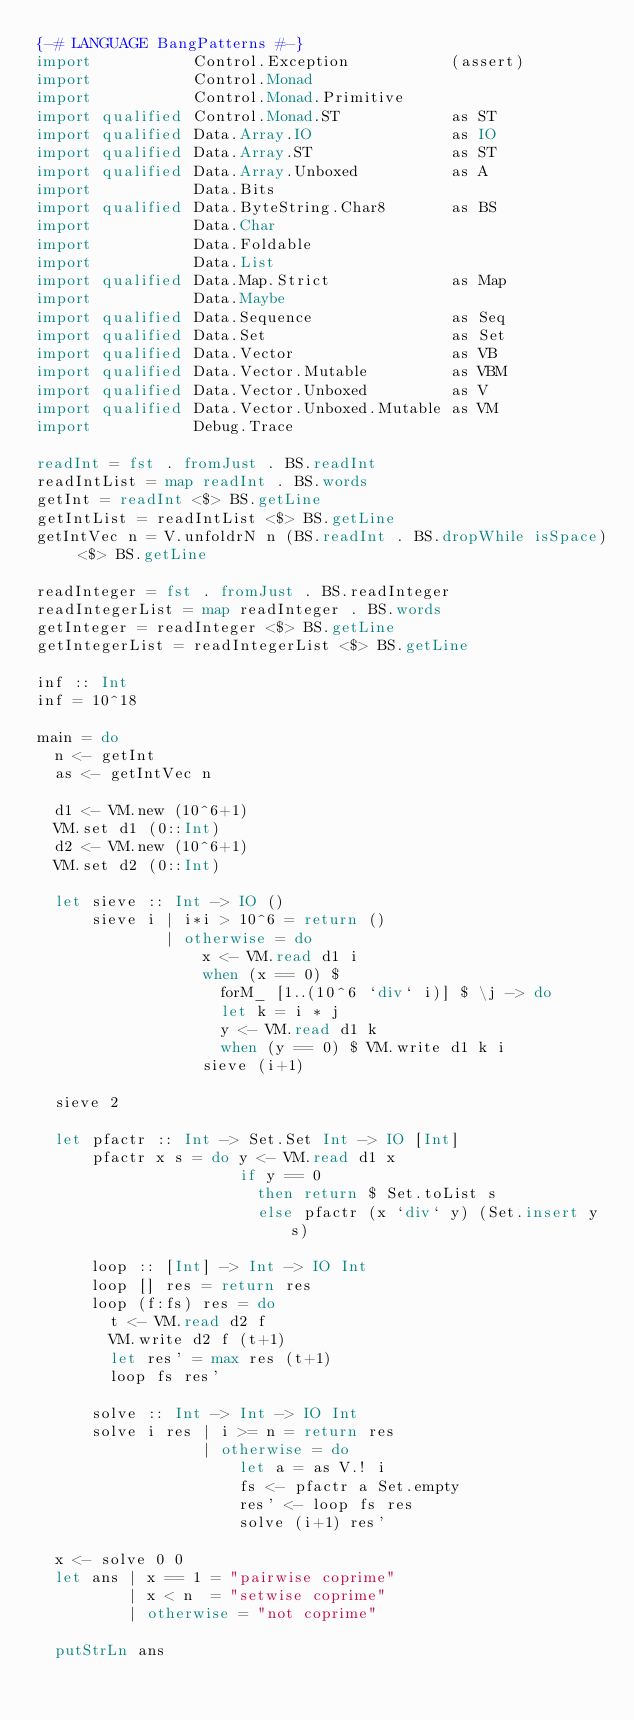<code> <loc_0><loc_0><loc_500><loc_500><_Haskell_>{-# LANGUAGE BangPatterns #-}
import           Control.Exception           (assert)
import           Control.Monad
import           Control.Monad.Primitive
import qualified Control.Monad.ST            as ST
import qualified Data.Array.IO               as IO
import qualified Data.Array.ST               as ST
import qualified Data.Array.Unboxed          as A
import           Data.Bits
import qualified Data.ByteString.Char8       as BS
import           Data.Char
import           Data.Foldable
import           Data.List
import qualified Data.Map.Strict             as Map
import           Data.Maybe
import qualified Data.Sequence               as Seq
import qualified Data.Set                    as Set
import qualified Data.Vector                 as VB
import qualified Data.Vector.Mutable         as VBM
import qualified Data.Vector.Unboxed         as V
import qualified Data.Vector.Unboxed.Mutable as VM
import           Debug.Trace

readInt = fst . fromJust . BS.readInt
readIntList = map readInt . BS.words
getInt = readInt <$> BS.getLine
getIntList = readIntList <$> BS.getLine
getIntVec n = V.unfoldrN n (BS.readInt . BS.dropWhile isSpace) <$> BS.getLine

readInteger = fst . fromJust . BS.readInteger
readIntegerList = map readInteger . BS.words
getInteger = readInteger <$> BS.getLine
getIntegerList = readIntegerList <$> BS.getLine

inf :: Int
inf = 10^18

main = do
  n <- getInt
  as <- getIntVec n

  d1 <- VM.new (10^6+1)
  VM.set d1 (0::Int)
  d2 <- VM.new (10^6+1)
  VM.set d2 (0::Int)

  let sieve :: Int -> IO ()
      sieve i | i*i > 10^6 = return ()
              | otherwise = do
                  x <- VM.read d1 i
                  when (x == 0) $
                    forM_ [1..(10^6 `div` i)] $ \j -> do
                    let k = i * j
                    y <- VM.read d1 k
                    when (y == 0) $ VM.write d1 k i
                  sieve (i+1)

  sieve 2

  let pfactr :: Int -> Set.Set Int -> IO [Int]
      pfactr x s = do y <- VM.read d1 x
                      if y == 0
                        then return $ Set.toList s
                        else pfactr (x `div` y) (Set.insert y s)

      loop :: [Int] -> Int -> IO Int
      loop [] res = return res
      loop (f:fs) res = do
        t <- VM.read d2 f
        VM.write d2 f (t+1)
        let res' = max res (t+1)
        loop fs res'

      solve :: Int -> Int -> IO Int
      solve i res | i >= n = return res
                  | otherwise = do
                      let a = as V.! i
                      fs <- pfactr a Set.empty
                      res' <- loop fs res
                      solve (i+1) res'

  x <- solve 0 0
  let ans | x == 1 = "pairwise coprime"
          | x < n  = "setwise coprime"
          | otherwise = "not coprime"

  putStrLn ans
</code> 